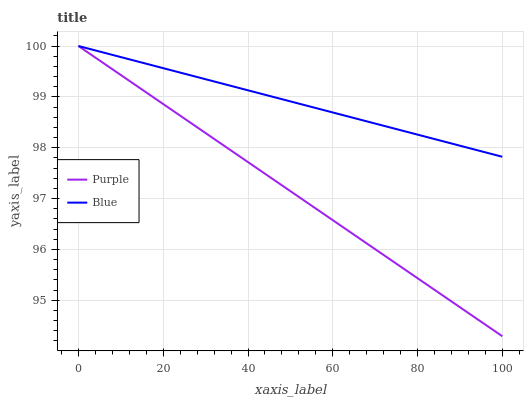Does Purple have the minimum area under the curve?
Answer yes or no. Yes. Does Blue have the maximum area under the curve?
Answer yes or no. Yes. Does Blue have the minimum area under the curve?
Answer yes or no. No. Is Blue the smoothest?
Answer yes or no. Yes. Is Purple the roughest?
Answer yes or no. Yes. Is Blue the roughest?
Answer yes or no. No. Does Blue have the lowest value?
Answer yes or no. No. Does Blue have the highest value?
Answer yes or no. Yes. Does Purple intersect Blue?
Answer yes or no. Yes. Is Purple less than Blue?
Answer yes or no. No. Is Purple greater than Blue?
Answer yes or no. No. 